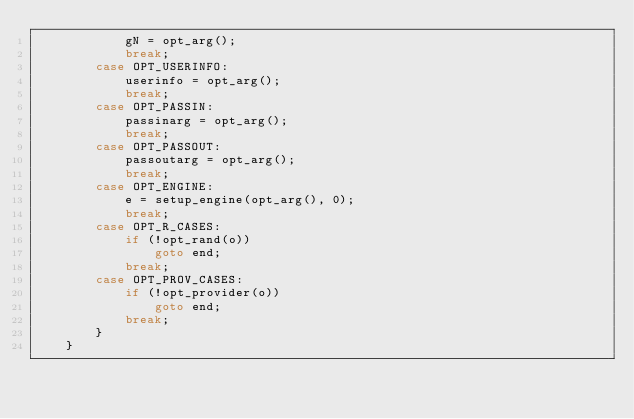<code> <loc_0><loc_0><loc_500><loc_500><_C_>            gN = opt_arg();
            break;
        case OPT_USERINFO:
            userinfo = opt_arg();
            break;
        case OPT_PASSIN:
            passinarg = opt_arg();
            break;
        case OPT_PASSOUT:
            passoutarg = opt_arg();
            break;
        case OPT_ENGINE:
            e = setup_engine(opt_arg(), 0);
            break;
        case OPT_R_CASES:
            if (!opt_rand(o))
                goto end;
            break;
        case OPT_PROV_CASES:
            if (!opt_provider(o))
                goto end;
            break;
        }
    }
</code> 